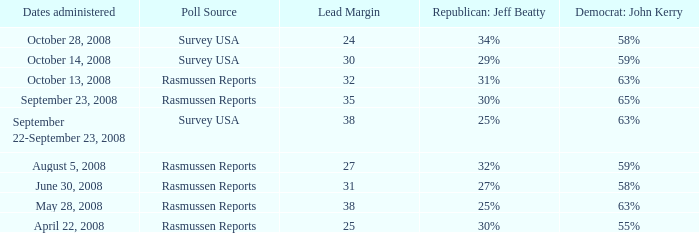Parse the full table. {'header': ['Dates administered', 'Poll Source', 'Lead Margin', 'Republican: Jeff Beatty', 'Democrat: John Kerry'], 'rows': [['October 28, 2008', 'Survey USA', '24', '34%', '58%'], ['October 14, 2008', 'Survey USA', '30', '29%', '59%'], ['October 13, 2008', 'Rasmussen Reports', '32', '31%', '63%'], ['September 23, 2008', 'Rasmussen Reports', '35', '30%', '65%'], ['September 22-September 23, 2008', 'Survey USA', '38', '25%', '63%'], ['August 5, 2008', 'Rasmussen Reports', '27', '32%', '59%'], ['June 30, 2008', 'Rasmussen Reports', '31', '27%', '58%'], ['May 28, 2008', 'Rasmussen Reports', '38', '25%', '63%'], ['April 22, 2008', 'Rasmussen Reports', '25', '30%', '55%']]} What is the percentage for john kerry and dates administered is april 22, 2008? 55%. 